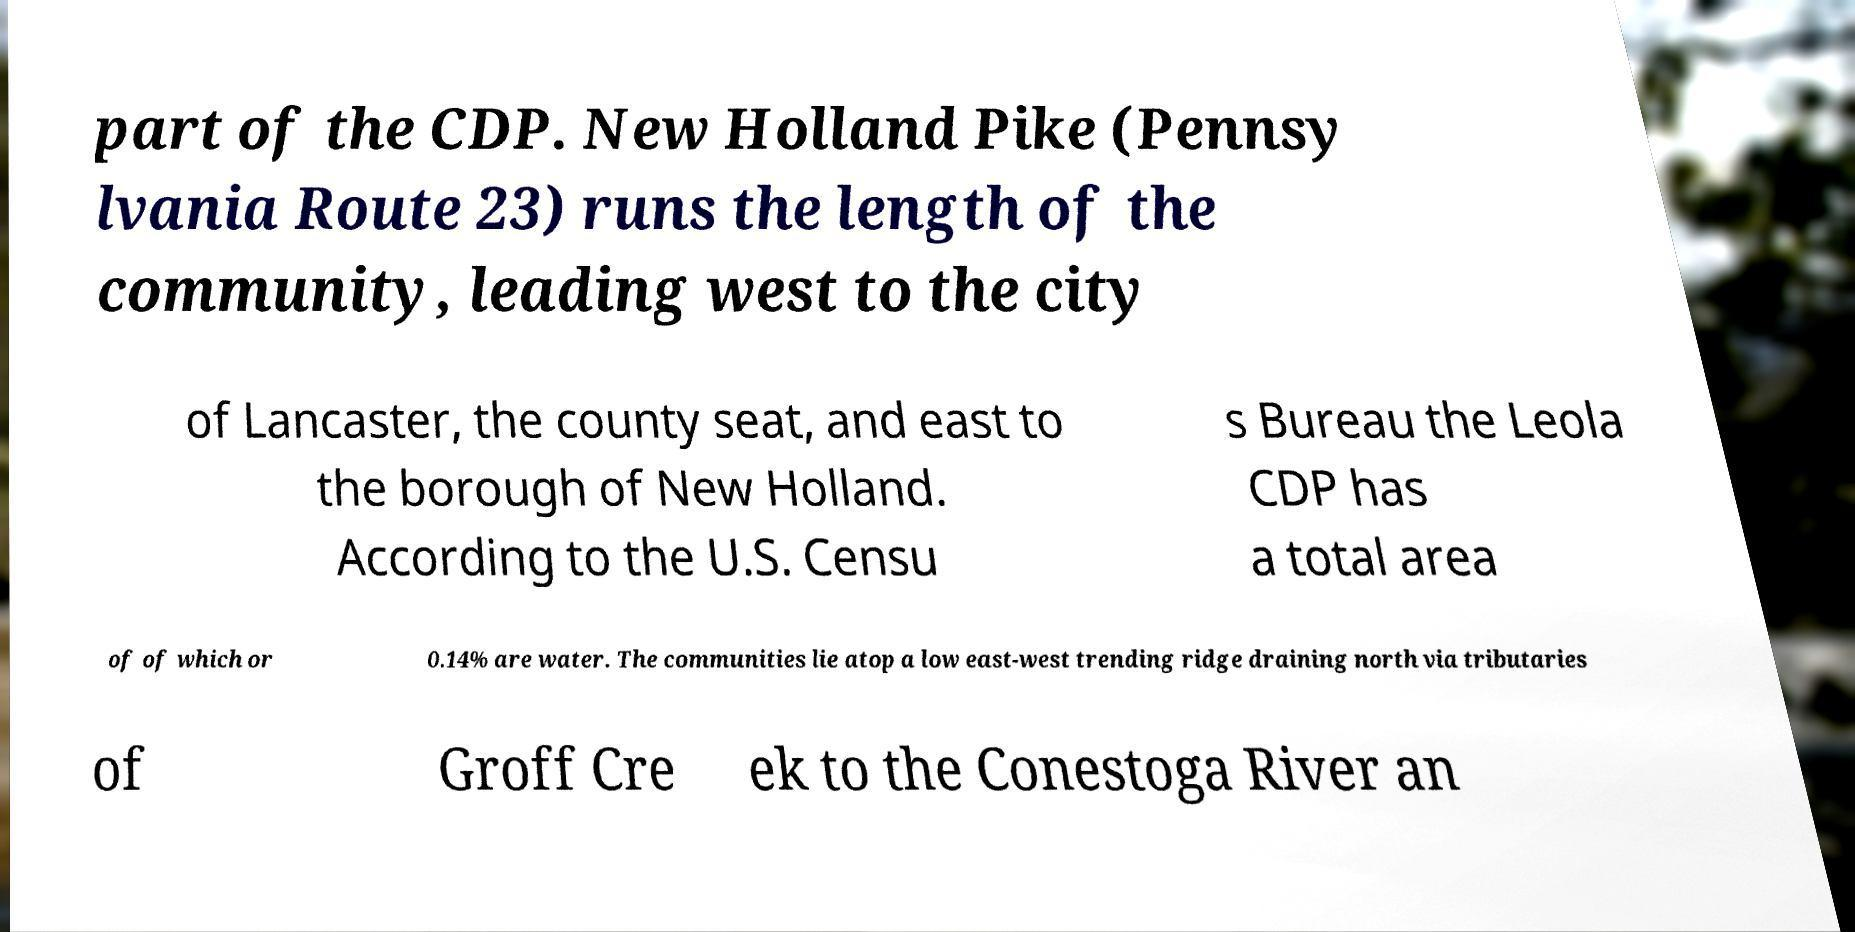There's text embedded in this image that I need extracted. Can you transcribe it verbatim? part of the CDP. New Holland Pike (Pennsy lvania Route 23) runs the length of the community, leading west to the city of Lancaster, the county seat, and east to the borough of New Holland. According to the U.S. Censu s Bureau the Leola CDP has a total area of of which or 0.14% are water. The communities lie atop a low east-west trending ridge draining north via tributaries of Groff Cre ek to the Conestoga River an 